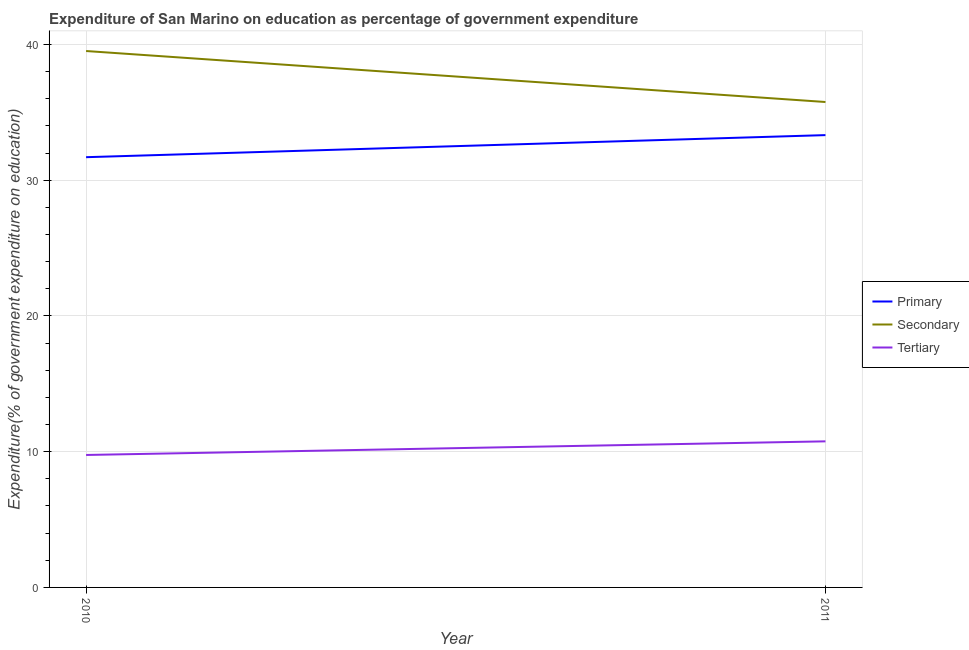Does the line corresponding to expenditure on tertiary education intersect with the line corresponding to expenditure on primary education?
Offer a very short reply. No. Is the number of lines equal to the number of legend labels?
Ensure brevity in your answer.  Yes. What is the expenditure on tertiary education in 2011?
Make the answer very short. 10.76. Across all years, what is the maximum expenditure on secondary education?
Provide a succinct answer. 39.52. Across all years, what is the minimum expenditure on secondary education?
Give a very brief answer. 35.76. What is the total expenditure on primary education in the graph?
Make the answer very short. 65.02. What is the difference between the expenditure on tertiary education in 2010 and that in 2011?
Provide a short and direct response. -1. What is the difference between the expenditure on secondary education in 2010 and the expenditure on primary education in 2011?
Provide a short and direct response. 6.2. What is the average expenditure on primary education per year?
Make the answer very short. 32.51. In the year 2011, what is the difference between the expenditure on primary education and expenditure on secondary education?
Provide a succinct answer. -2.44. In how many years, is the expenditure on primary education greater than 8 %?
Your response must be concise. 2. What is the ratio of the expenditure on secondary education in 2010 to that in 2011?
Your response must be concise. 1.11. Is the expenditure on tertiary education in 2010 less than that in 2011?
Your answer should be very brief. Yes. Is it the case that in every year, the sum of the expenditure on primary education and expenditure on secondary education is greater than the expenditure on tertiary education?
Ensure brevity in your answer.  Yes. Is the expenditure on tertiary education strictly less than the expenditure on primary education over the years?
Offer a terse response. Yes. Are the values on the major ticks of Y-axis written in scientific E-notation?
Provide a short and direct response. No. Does the graph contain grids?
Keep it short and to the point. Yes. How are the legend labels stacked?
Your answer should be compact. Vertical. What is the title of the graph?
Offer a terse response. Expenditure of San Marino on education as percentage of government expenditure. What is the label or title of the X-axis?
Provide a succinct answer. Year. What is the label or title of the Y-axis?
Provide a succinct answer. Expenditure(% of government expenditure on education). What is the Expenditure(% of government expenditure on education) in Primary in 2010?
Provide a succinct answer. 31.7. What is the Expenditure(% of government expenditure on education) of Secondary in 2010?
Keep it short and to the point. 39.52. What is the Expenditure(% of government expenditure on education) in Tertiary in 2010?
Provide a succinct answer. 9.76. What is the Expenditure(% of government expenditure on education) in Primary in 2011?
Your answer should be compact. 33.32. What is the Expenditure(% of government expenditure on education) in Secondary in 2011?
Ensure brevity in your answer.  35.76. What is the Expenditure(% of government expenditure on education) of Tertiary in 2011?
Provide a succinct answer. 10.76. Across all years, what is the maximum Expenditure(% of government expenditure on education) of Primary?
Provide a short and direct response. 33.32. Across all years, what is the maximum Expenditure(% of government expenditure on education) of Secondary?
Provide a succinct answer. 39.52. Across all years, what is the maximum Expenditure(% of government expenditure on education) of Tertiary?
Give a very brief answer. 10.76. Across all years, what is the minimum Expenditure(% of government expenditure on education) of Primary?
Keep it short and to the point. 31.7. Across all years, what is the minimum Expenditure(% of government expenditure on education) of Secondary?
Your answer should be compact. 35.76. Across all years, what is the minimum Expenditure(% of government expenditure on education) of Tertiary?
Provide a succinct answer. 9.76. What is the total Expenditure(% of government expenditure on education) in Primary in the graph?
Make the answer very short. 65.02. What is the total Expenditure(% of government expenditure on education) in Secondary in the graph?
Offer a very short reply. 75.28. What is the total Expenditure(% of government expenditure on education) of Tertiary in the graph?
Your response must be concise. 20.52. What is the difference between the Expenditure(% of government expenditure on education) of Primary in 2010 and that in 2011?
Ensure brevity in your answer.  -1.63. What is the difference between the Expenditure(% of government expenditure on education) in Secondary in 2010 and that in 2011?
Your answer should be very brief. 3.76. What is the difference between the Expenditure(% of government expenditure on education) in Tertiary in 2010 and that in 2011?
Give a very brief answer. -1. What is the difference between the Expenditure(% of government expenditure on education) in Primary in 2010 and the Expenditure(% of government expenditure on education) in Secondary in 2011?
Keep it short and to the point. -4.07. What is the difference between the Expenditure(% of government expenditure on education) of Primary in 2010 and the Expenditure(% of government expenditure on education) of Tertiary in 2011?
Give a very brief answer. 20.93. What is the difference between the Expenditure(% of government expenditure on education) of Secondary in 2010 and the Expenditure(% of government expenditure on education) of Tertiary in 2011?
Your response must be concise. 28.76. What is the average Expenditure(% of government expenditure on education) in Primary per year?
Keep it short and to the point. 32.51. What is the average Expenditure(% of government expenditure on education) in Secondary per year?
Ensure brevity in your answer.  37.64. What is the average Expenditure(% of government expenditure on education) of Tertiary per year?
Keep it short and to the point. 10.26. In the year 2010, what is the difference between the Expenditure(% of government expenditure on education) of Primary and Expenditure(% of government expenditure on education) of Secondary?
Provide a succinct answer. -7.82. In the year 2010, what is the difference between the Expenditure(% of government expenditure on education) of Primary and Expenditure(% of government expenditure on education) of Tertiary?
Give a very brief answer. 21.94. In the year 2010, what is the difference between the Expenditure(% of government expenditure on education) in Secondary and Expenditure(% of government expenditure on education) in Tertiary?
Offer a very short reply. 29.76. In the year 2011, what is the difference between the Expenditure(% of government expenditure on education) in Primary and Expenditure(% of government expenditure on education) in Secondary?
Provide a succinct answer. -2.44. In the year 2011, what is the difference between the Expenditure(% of government expenditure on education) of Primary and Expenditure(% of government expenditure on education) of Tertiary?
Your answer should be very brief. 22.56. In the year 2011, what is the difference between the Expenditure(% of government expenditure on education) of Secondary and Expenditure(% of government expenditure on education) of Tertiary?
Your answer should be very brief. 25. What is the ratio of the Expenditure(% of government expenditure on education) in Primary in 2010 to that in 2011?
Give a very brief answer. 0.95. What is the ratio of the Expenditure(% of government expenditure on education) of Secondary in 2010 to that in 2011?
Give a very brief answer. 1.1. What is the ratio of the Expenditure(% of government expenditure on education) in Tertiary in 2010 to that in 2011?
Ensure brevity in your answer.  0.91. What is the difference between the highest and the second highest Expenditure(% of government expenditure on education) in Primary?
Your answer should be compact. 1.63. What is the difference between the highest and the second highest Expenditure(% of government expenditure on education) of Secondary?
Offer a very short reply. 3.76. What is the difference between the highest and the second highest Expenditure(% of government expenditure on education) in Tertiary?
Give a very brief answer. 1. What is the difference between the highest and the lowest Expenditure(% of government expenditure on education) of Primary?
Your answer should be very brief. 1.63. What is the difference between the highest and the lowest Expenditure(% of government expenditure on education) of Secondary?
Give a very brief answer. 3.76. What is the difference between the highest and the lowest Expenditure(% of government expenditure on education) in Tertiary?
Your response must be concise. 1. 